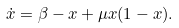<formula> <loc_0><loc_0><loc_500><loc_500>\dot { x } = \beta - x + \mu x ( 1 - x ) .</formula> 